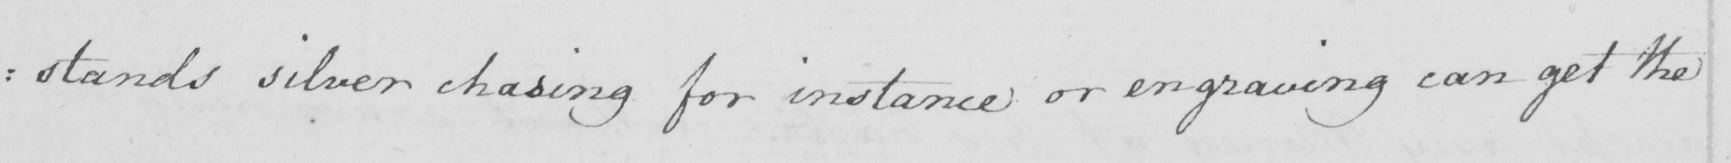What is written in this line of handwriting? : stands silver chasing for instance or engraving can get the 